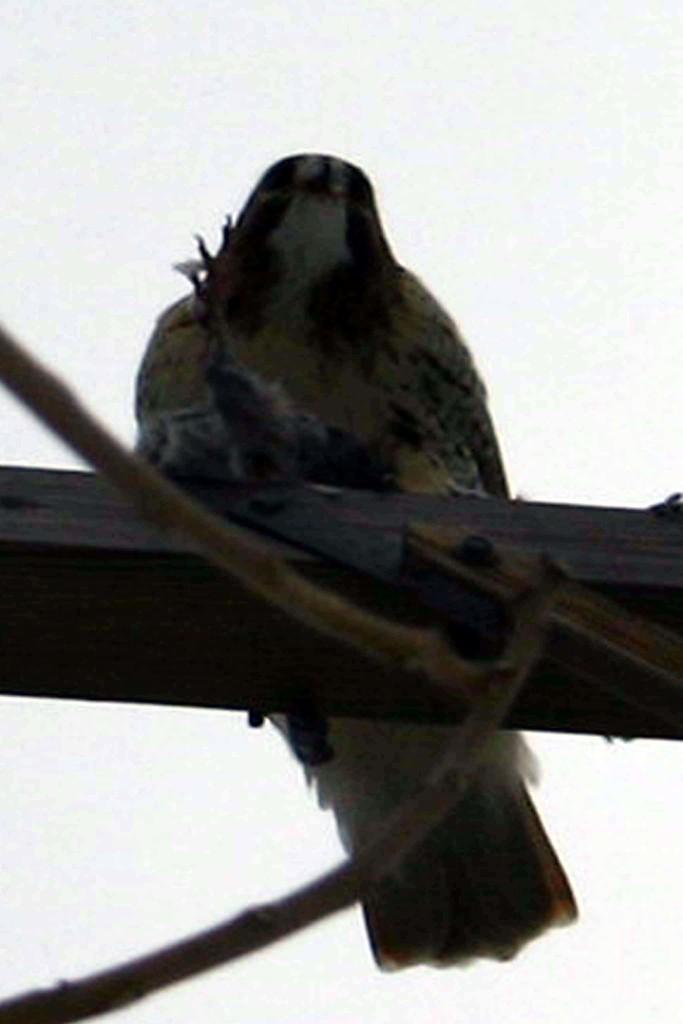What type of bird is in the picture? There is a black color bird in the picture. What is the color of the background in the picture? The background of the picture is in white color. What can be seen in the background of the picture? The background appears to have twigs. What type of organization is depicted in the picture? There is no organization depicted in the picture; it features a black color bird and a white background with twigs. Can you tell me how many cars are visible in the picture? There are no cars present in the picture. 